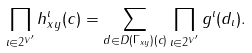<formula> <loc_0><loc_0><loc_500><loc_500>\prod _ { \iota \in 2 ^ { V ^ { \prime } } } h _ { x y } ^ { \iota } ( c ) = \sum _ { d \in D ( \Gamma _ { x y } ) ( c ) } \prod _ { \iota \in 2 ^ { V ^ { \prime } } } g ^ { \iota } ( d _ { \iota } ) .</formula> 